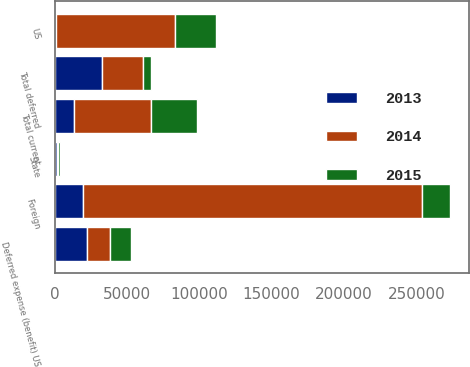<chart> <loc_0><loc_0><loc_500><loc_500><stacked_bar_chart><ecel><fcel>US<fcel>Foreign<fcel>Total current<fcel>Deferred expense (benefit) US<fcel>State<fcel>Total deferred<nl><fcel>2013<fcel>944<fcel>19322.5<fcel>13393<fcel>22641<fcel>1562<fcel>32811<nl><fcel>2015<fcel>28245<fcel>19322.5<fcel>31753<fcel>14445<fcel>929<fcel>5320<nl><fcel>2014<fcel>82163<fcel>234340<fcel>53156<fcel>16004<fcel>1111<fcel>28368<nl></chart> 